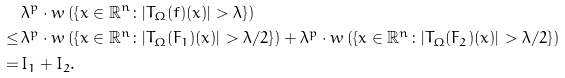<formula> <loc_0><loc_0><loc_500><loc_500>& \lambda ^ { p } \cdot w \left ( \left \{ x \in \mathbb { R } ^ { n } \colon | T _ { \Omega } ( f ) ( x ) | > \lambda \right \} \right ) \\ \leq \, & \lambda ^ { p } \cdot w \left ( \left \{ x \in \mathbb { R } ^ { n } \colon | T _ { \Omega } ( F _ { 1 } ) ( x ) | > \lambda / 2 \right \} \right ) + \lambda ^ { p } \cdot w \left ( \left \{ x \in \mathbb { R } ^ { n } \colon | T _ { \Omega } ( F _ { 2 } ) ( x ) | > \lambda / 2 \right \} \right ) \\ = \, & I _ { 1 } + I _ { 2 } .</formula> 